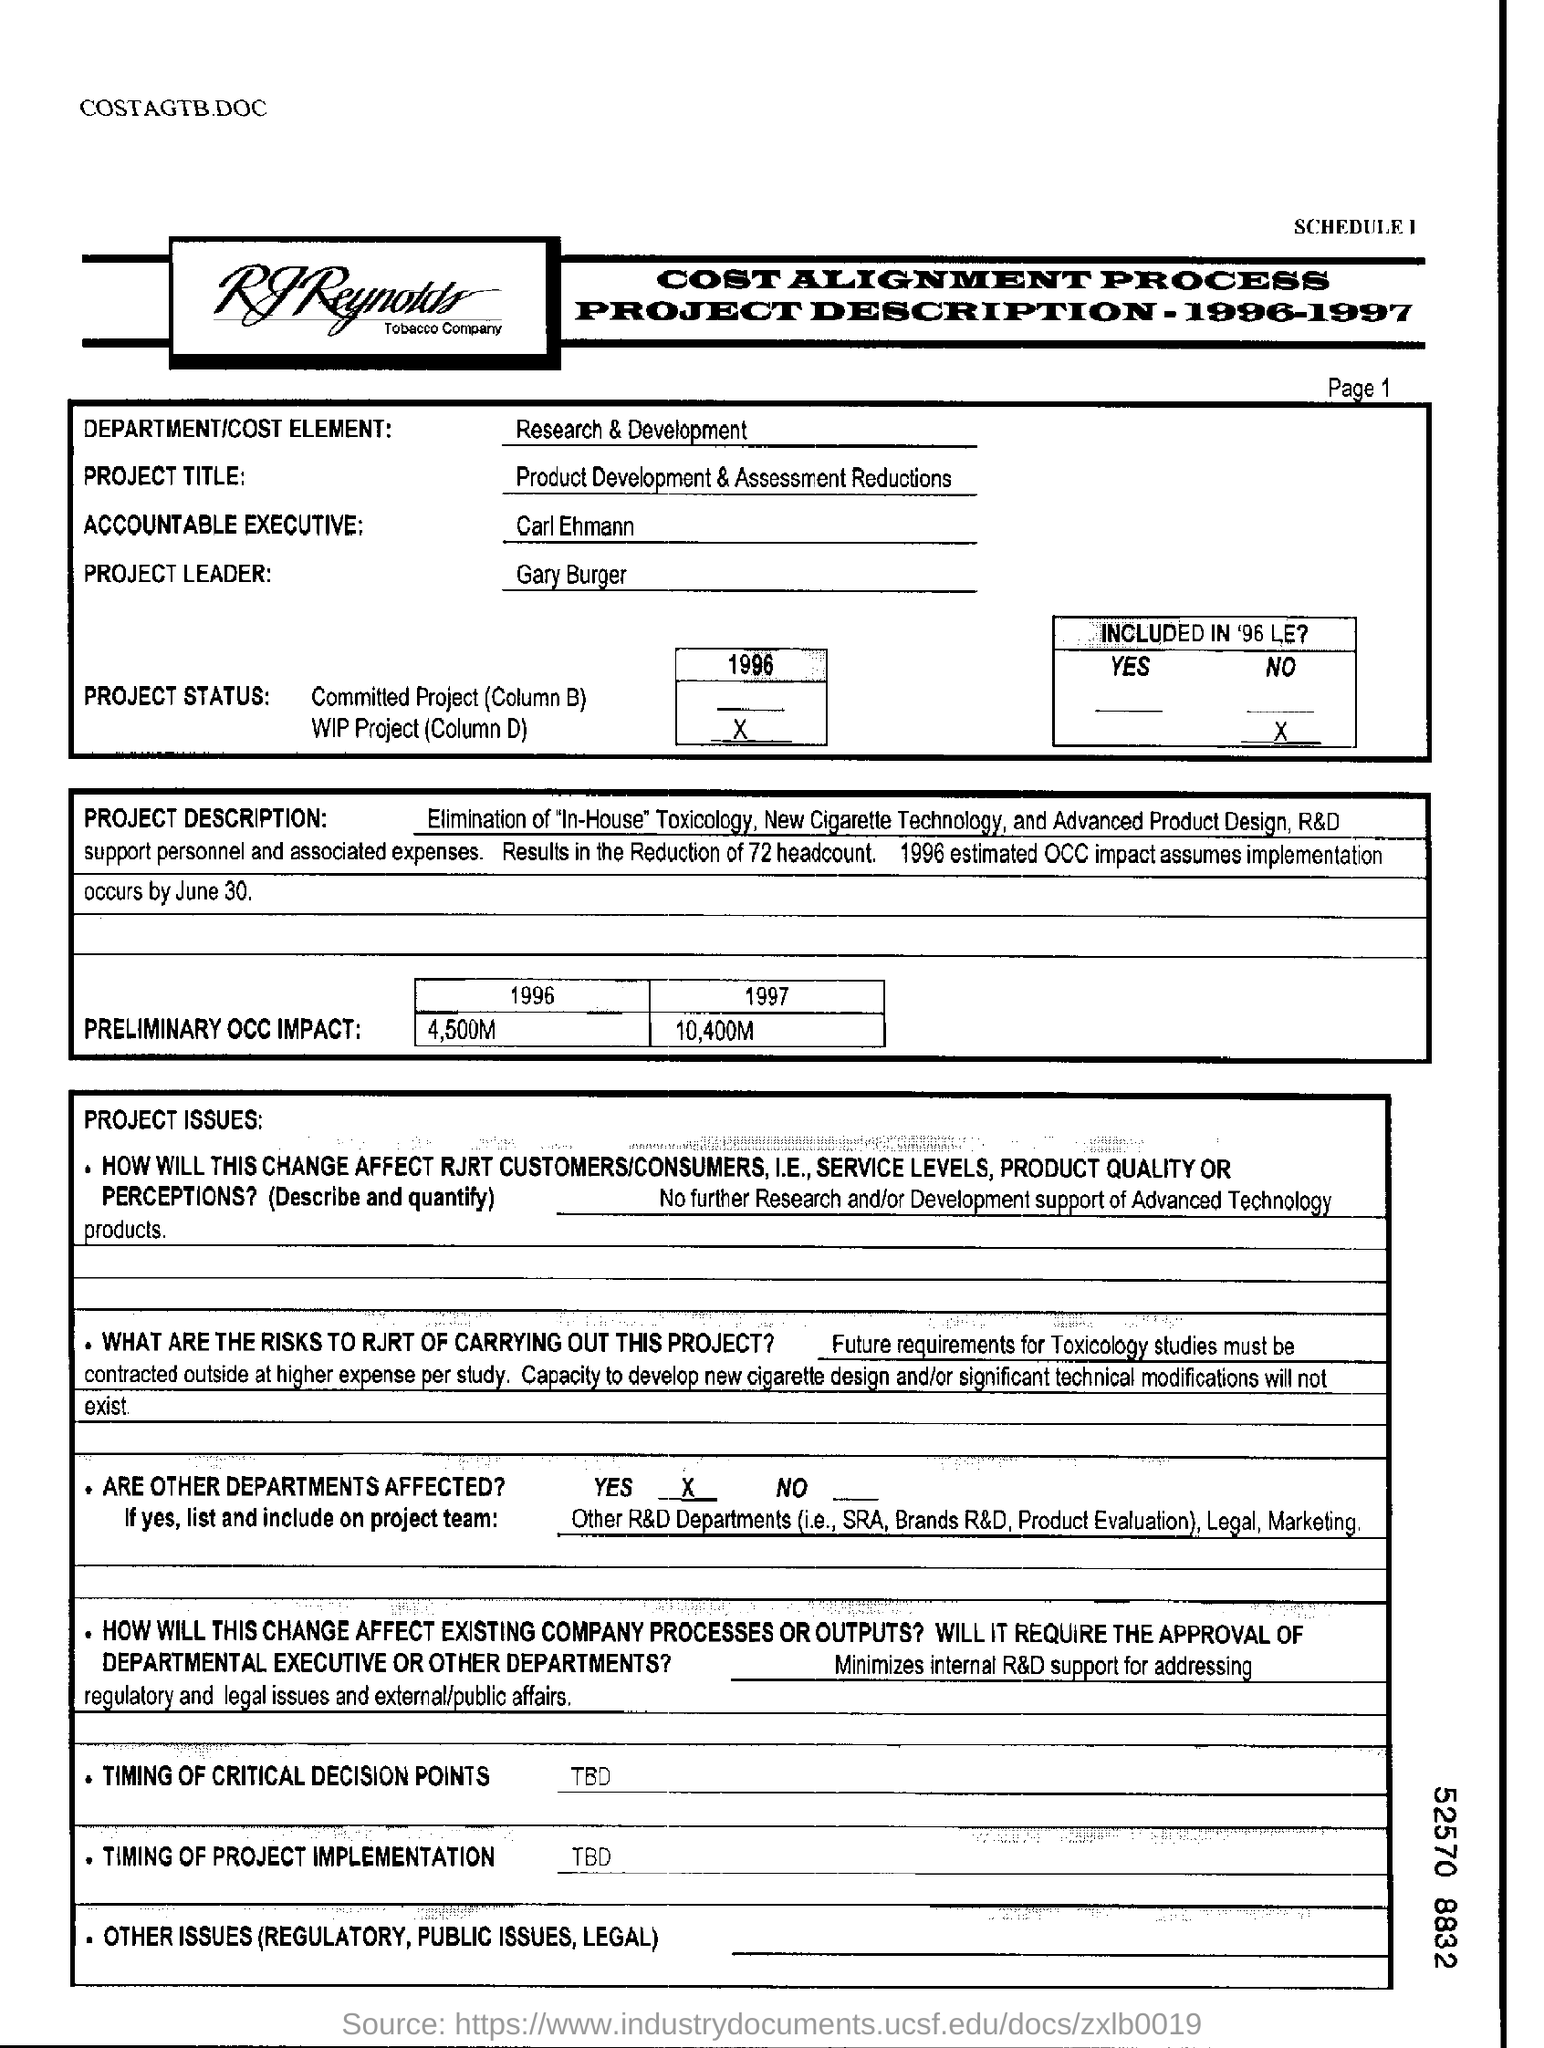Who is the project leader?
Give a very brief answer. Gary burger. Which department is involved?
Provide a short and direct response. Research & Development. What is the preliminary OCC impact in the year 1997?
Your response must be concise. 10,400M. 